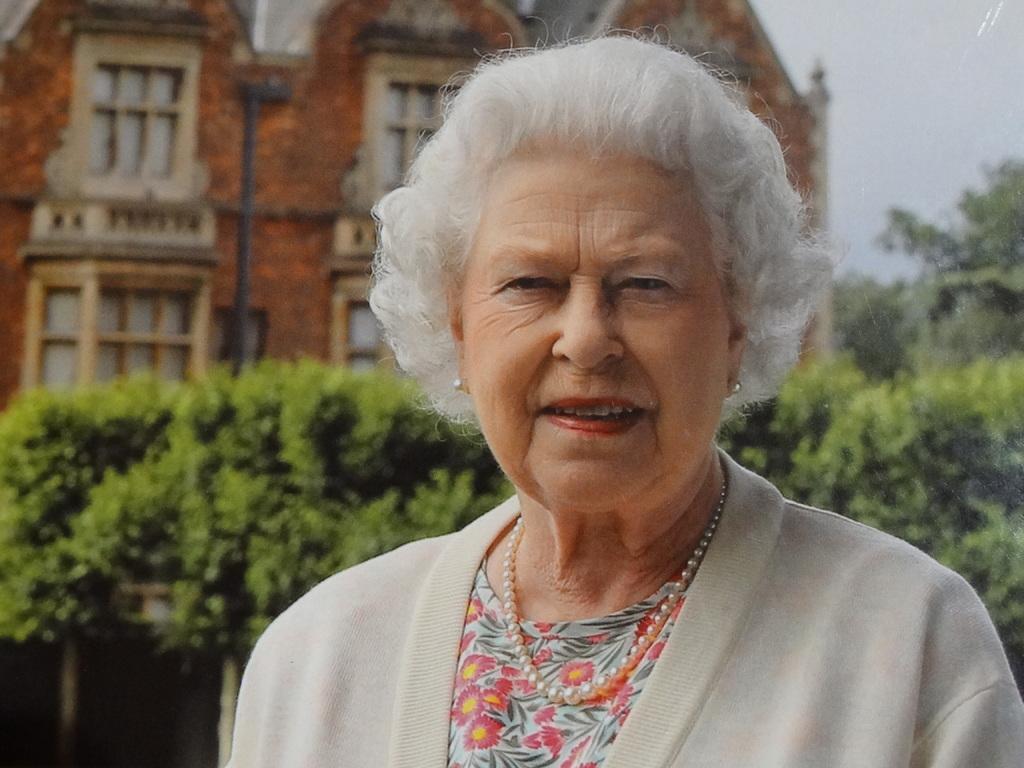How would you summarize this image in a sentence or two? In this picture there is a woman smiling. In the background of the image we can see plants, trees, building, pole and sky. 